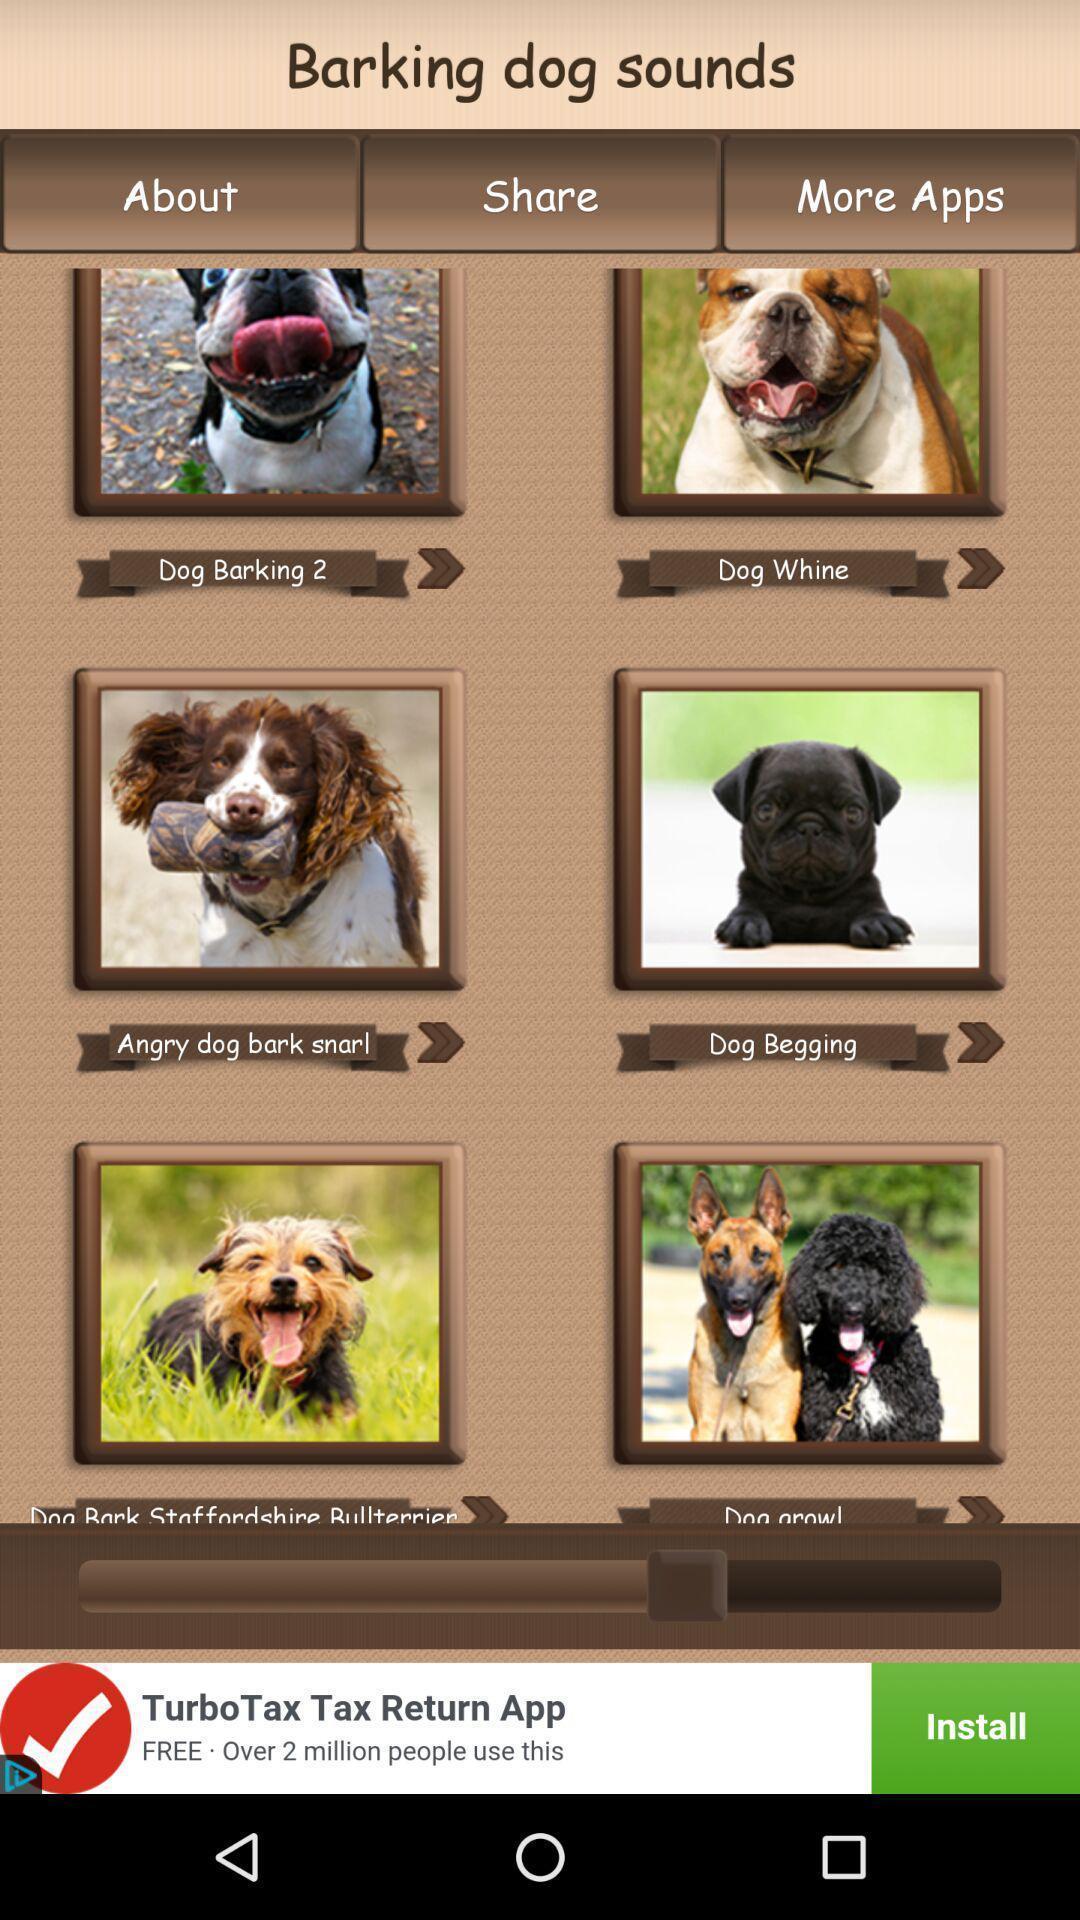Summarize the main components in this picture. Various dog barking sounds in the application. 